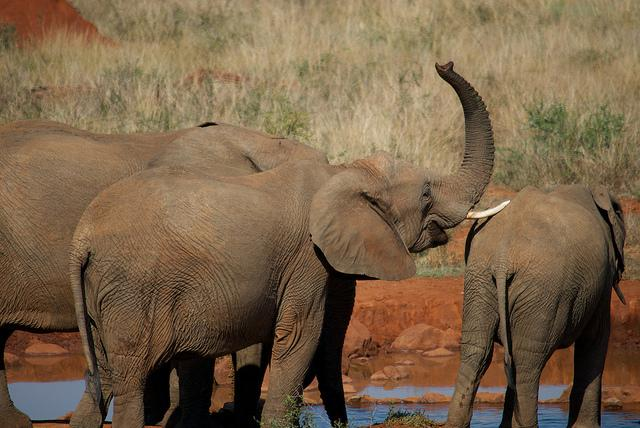What is not unique about this animals? skin 